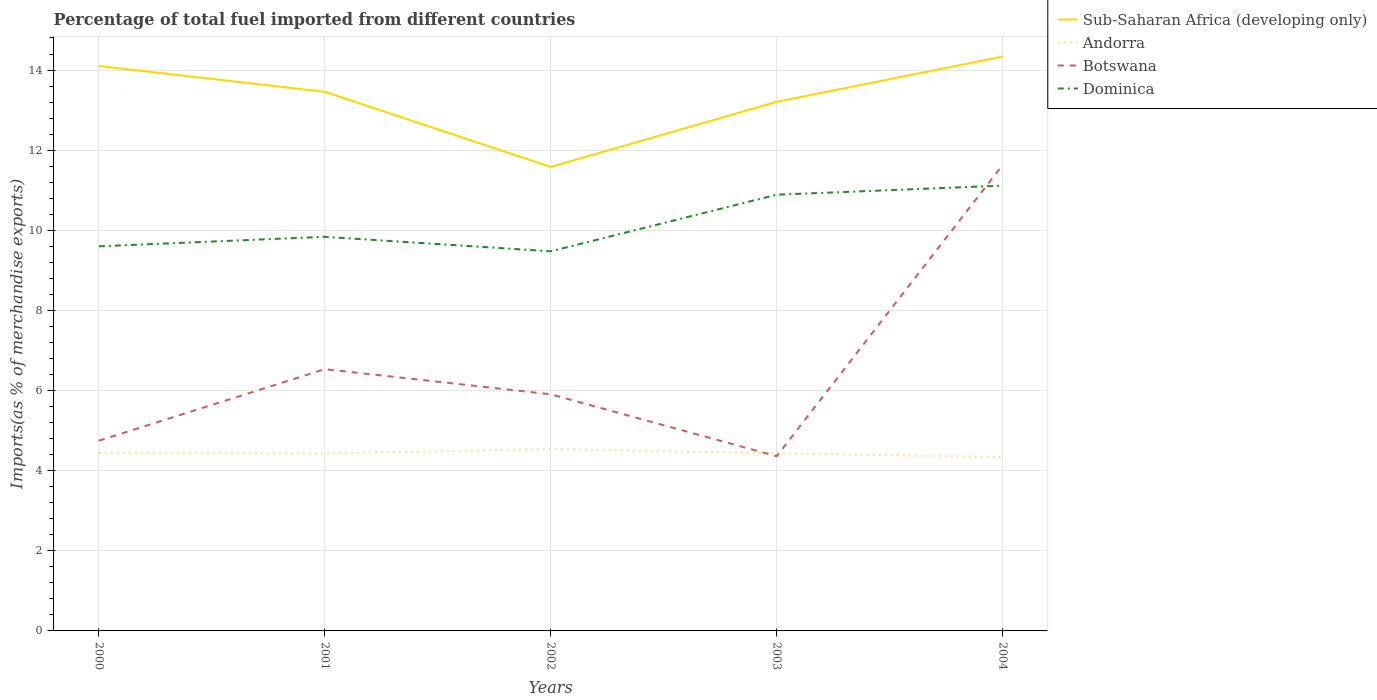How many different coloured lines are there?
Your answer should be compact. 4. Is the number of lines equal to the number of legend labels?
Keep it short and to the point. Yes. Across all years, what is the maximum percentage of imports to different countries in Andorra?
Ensure brevity in your answer.  4.34. What is the total percentage of imports to different countries in Andorra in the graph?
Keep it short and to the point. 0.09. What is the difference between the highest and the second highest percentage of imports to different countries in Andorra?
Offer a very short reply. 0.2. What is the difference between the highest and the lowest percentage of imports to different countries in Botswana?
Your answer should be compact. 1. How many lines are there?
Your answer should be very brief. 4. How many years are there in the graph?
Ensure brevity in your answer.  5. Are the values on the major ticks of Y-axis written in scientific E-notation?
Provide a short and direct response. No. Where does the legend appear in the graph?
Ensure brevity in your answer.  Top right. What is the title of the graph?
Your response must be concise. Percentage of total fuel imported from different countries. What is the label or title of the Y-axis?
Ensure brevity in your answer.  Imports(as % of merchandise exports). What is the Imports(as % of merchandise exports) of Sub-Saharan Africa (developing only) in 2000?
Your answer should be compact. 14.1. What is the Imports(as % of merchandise exports) of Andorra in 2000?
Ensure brevity in your answer.  4.44. What is the Imports(as % of merchandise exports) in Botswana in 2000?
Your answer should be very brief. 4.75. What is the Imports(as % of merchandise exports) in Dominica in 2000?
Your response must be concise. 9.6. What is the Imports(as % of merchandise exports) in Sub-Saharan Africa (developing only) in 2001?
Offer a very short reply. 13.46. What is the Imports(as % of merchandise exports) in Andorra in 2001?
Provide a succinct answer. 4.43. What is the Imports(as % of merchandise exports) in Botswana in 2001?
Make the answer very short. 6.53. What is the Imports(as % of merchandise exports) of Dominica in 2001?
Keep it short and to the point. 9.84. What is the Imports(as % of merchandise exports) in Sub-Saharan Africa (developing only) in 2002?
Ensure brevity in your answer.  11.58. What is the Imports(as % of merchandise exports) of Andorra in 2002?
Provide a succinct answer. 4.54. What is the Imports(as % of merchandise exports) of Botswana in 2002?
Your answer should be very brief. 5.91. What is the Imports(as % of merchandise exports) in Dominica in 2002?
Provide a short and direct response. 9.48. What is the Imports(as % of merchandise exports) of Sub-Saharan Africa (developing only) in 2003?
Your response must be concise. 13.21. What is the Imports(as % of merchandise exports) of Andorra in 2003?
Ensure brevity in your answer.  4.43. What is the Imports(as % of merchandise exports) of Botswana in 2003?
Provide a short and direct response. 4.36. What is the Imports(as % of merchandise exports) in Dominica in 2003?
Offer a terse response. 10.89. What is the Imports(as % of merchandise exports) in Sub-Saharan Africa (developing only) in 2004?
Your response must be concise. 14.34. What is the Imports(as % of merchandise exports) in Andorra in 2004?
Ensure brevity in your answer.  4.34. What is the Imports(as % of merchandise exports) in Botswana in 2004?
Give a very brief answer. 11.63. What is the Imports(as % of merchandise exports) of Dominica in 2004?
Ensure brevity in your answer.  11.12. Across all years, what is the maximum Imports(as % of merchandise exports) of Sub-Saharan Africa (developing only)?
Your answer should be compact. 14.34. Across all years, what is the maximum Imports(as % of merchandise exports) of Andorra?
Keep it short and to the point. 4.54. Across all years, what is the maximum Imports(as % of merchandise exports) in Botswana?
Provide a short and direct response. 11.63. Across all years, what is the maximum Imports(as % of merchandise exports) of Dominica?
Make the answer very short. 11.12. Across all years, what is the minimum Imports(as % of merchandise exports) in Sub-Saharan Africa (developing only)?
Offer a very short reply. 11.58. Across all years, what is the minimum Imports(as % of merchandise exports) of Andorra?
Offer a very short reply. 4.34. Across all years, what is the minimum Imports(as % of merchandise exports) in Botswana?
Give a very brief answer. 4.36. Across all years, what is the minimum Imports(as % of merchandise exports) of Dominica?
Your answer should be very brief. 9.48. What is the total Imports(as % of merchandise exports) in Sub-Saharan Africa (developing only) in the graph?
Provide a succinct answer. 66.68. What is the total Imports(as % of merchandise exports) of Andorra in the graph?
Offer a terse response. 22.18. What is the total Imports(as % of merchandise exports) of Botswana in the graph?
Ensure brevity in your answer.  33.18. What is the total Imports(as % of merchandise exports) in Dominica in the graph?
Make the answer very short. 50.92. What is the difference between the Imports(as % of merchandise exports) of Sub-Saharan Africa (developing only) in 2000 and that in 2001?
Your response must be concise. 0.64. What is the difference between the Imports(as % of merchandise exports) in Andorra in 2000 and that in 2001?
Offer a terse response. 0.01. What is the difference between the Imports(as % of merchandise exports) in Botswana in 2000 and that in 2001?
Offer a very short reply. -1.79. What is the difference between the Imports(as % of merchandise exports) of Dominica in 2000 and that in 2001?
Provide a succinct answer. -0.24. What is the difference between the Imports(as % of merchandise exports) in Sub-Saharan Africa (developing only) in 2000 and that in 2002?
Ensure brevity in your answer.  2.52. What is the difference between the Imports(as % of merchandise exports) of Andorra in 2000 and that in 2002?
Offer a terse response. -0.1. What is the difference between the Imports(as % of merchandise exports) in Botswana in 2000 and that in 2002?
Your answer should be compact. -1.16. What is the difference between the Imports(as % of merchandise exports) of Dominica in 2000 and that in 2002?
Offer a terse response. 0.13. What is the difference between the Imports(as % of merchandise exports) in Sub-Saharan Africa (developing only) in 2000 and that in 2003?
Provide a succinct answer. 0.89. What is the difference between the Imports(as % of merchandise exports) in Andorra in 2000 and that in 2003?
Give a very brief answer. 0. What is the difference between the Imports(as % of merchandise exports) of Botswana in 2000 and that in 2003?
Your response must be concise. 0.39. What is the difference between the Imports(as % of merchandise exports) in Dominica in 2000 and that in 2003?
Make the answer very short. -1.29. What is the difference between the Imports(as % of merchandise exports) of Sub-Saharan Africa (developing only) in 2000 and that in 2004?
Your response must be concise. -0.24. What is the difference between the Imports(as % of merchandise exports) in Andorra in 2000 and that in 2004?
Keep it short and to the point. 0.1. What is the difference between the Imports(as % of merchandise exports) in Botswana in 2000 and that in 2004?
Your response must be concise. -6.88. What is the difference between the Imports(as % of merchandise exports) in Dominica in 2000 and that in 2004?
Ensure brevity in your answer.  -1.52. What is the difference between the Imports(as % of merchandise exports) of Sub-Saharan Africa (developing only) in 2001 and that in 2002?
Your answer should be very brief. 1.88. What is the difference between the Imports(as % of merchandise exports) in Andorra in 2001 and that in 2002?
Make the answer very short. -0.11. What is the difference between the Imports(as % of merchandise exports) in Botswana in 2001 and that in 2002?
Ensure brevity in your answer.  0.63. What is the difference between the Imports(as % of merchandise exports) in Dominica in 2001 and that in 2002?
Your answer should be very brief. 0.36. What is the difference between the Imports(as % of merchandise exports) of Sub-Saharan Africa (developing only) in 2001 and that in 2003?
Your answer should be compact. 0.25. What is the difference between the Imports(as % of merchandise exports) in Andorra in 2001 and that in 2003?
Offer a terse response. -0. What is the difference between the Imports(as % of merchandise exports) in Botswana in 2001 and that in 2003?
Provide a short and direct response. 2.17. What is the difference between the Imports(as % of merchandise exports) in Dominica in 2001 and that in 2003?
Keep it short and to the point. -1.05. What is the difference between the Imports(as % of merchandise exports) in Sub-Saharan Africa (developing only) in 2001 and that in 2004?
Your answer should be compact. -0.88. What is the difference between the Imports(as % of merchandise exports) in Andorra in 2001 and that in 2004?
Offer a very short reply. 0.09. What is the difference between the Imports(as % of merchandise exports) in Botswana in 2001 and that in 2004?
Give a very brief answer. -5.09. What is the difference between the Imports(as % of merchandise exports) of Dominica in 2001 and that in 2004?
Provide a short and direct response. -1.28. What is the difference between the Imports(as % of merchandise exports) of Sub-Saharan Africa (developing only) in 2002 and that in 2003?
Give a very brief answer. -1.63. What is the difference between the Imports(as % of merchandise exports) in Andorra in 2002 and that in 2003?
Your answer should be compact. 0.11. What is the difference between the Imports(as % of merchandise exports) of Botswana in 2002 and that in 2003?
Make the answer very short. 1.55. What is the difference between the Imports(as % of merchandise exports) in Dominica in 2002 and that in 2003?
Ensure brevity in your answer.  -1.41. What is the difference between the Imports(as % of merchandise exports) of Sub-Saharan Africa (developing only) in 2002 and that in 2004?
Make the answer very short. -2.75. What is the difference between the Imports(as % of merchandise exports) in Andorra in 2002 and that in 2004?
Offer a terse response. 0.2. What is the difference between the Imports(as % of merchandise exports) in Botswana in 2002 and that in 2004?
Provide a short and direct response. -5.72. What is the difference between the Imports(as % of merchandise exports) in Dominica in 2002 and that in 2004?
Offer a terse response. -1.64. What is the difference between the Imports(as % of merchandise exports) of Sub-Saharan Africa (developing only) in 2003 and that in 2004?
Ensure brevity in your answer.  -1.13. What is the difference between the Imports(as % of merchandise exports) in Andorra in 2003 and that in 2004?
Provide a short and direct response. 0.1. What is the difference between the Imports(as % of merchandise exports) in Botswana in 2003 and that in 2004?
Make the answer very short. -7.27. What is the difference between the Imports(as % of merchandise exports) of Dominica in 2003 and that in 2004?
Keep it short and to the point. -0.23. What is the difference between the Imports(as % of merchandise exports) of Sub-Saharan Africa (developing only) in 2000 and the Imports(as % of merchandise exports) of Andorra in 2001?
Provide a succinct answer. 9.67. What is the difference between the Imports(as % of merchandise exports) of Sub-Saharan Africa (developing only) in 2000 and the Imports(as % of merchandise exports) of Botswana in 2001?
Ensure brevity in your answer.  7.57. What is the difference between the Imports(as % of merchandise exports) of Sub-Saharan Africa (developing only) in 2000 and the Imports(as % of merchandise exports) of Dominica in 2001?
Make the answer very short. 4.26. What is the difference between the Imports(as % of merchandise exports) in Andorra in 2000 and the Imports(as % of merchandise exports) in Botswana in 2001?
Your answer should be compact. -2.09. What is the difference between the Imports(as % of merchandise exports) in Andorra in 2000 and the Imports(as % of merchandise exports) in Dominica in 2001?
Keep it short and to the point. -5.4. What is the difference between the Imports(as % of merchandise exports) in Botswana in 2000 and the Imports(as % of merchandise exports) in Dominica in 2001?
Your answer should be compact. -5.09. What is the difference between the Imports(as % of merchandise exports) in Sub-Saharan Africa (developing only) in 2000 and the Imports(as % of merchandise exports) in Andorra in 2002?
Your answer should be very brief. 9.56. What is the difference between the Imports(as % of merchandise exports) in Sub-Saharan Africa (developing only) in 2000 and the Imports(as % of merchandise exports) in Botswana in 2002?
Make the answer very short. 8.19. What is the difference between the Imports(as % of merchandise exports) in Sub-Saharan Africa (developing only) in 2000 and the Imports(as % of merchandise exports) in Dominica in 2002?
Offer a very short reply. 4.63. What is the difference between the Imports(as % of merchandise exports) of Andorra in 2000 and the Imports(as % of merchandise exports) of Botswana in 2002?
Your response must be concise. -1.47. What is the difference between the Imports(as % of merchandise exports) of Andorra in 2000 and the Imports(as % of merchandise exports) of Dominica in 2002?
Your answer should be compact. -5.04. What is the difference between the Imports(as % of merchandise exports) of Botswana in 2000 and the Imports(as % of merchandise exports) of Dominica in 2002?
Offer a terse response. -4.73. What is the difference between the Imports(as % of merchandise exports) in Sub-Saharan Africa (developing only) in 2000 and the Imports(as % of merchandise exports) in Andorra in 2003?
Give a very brief answer. 9.67. What is the difference between the Imports(as % of merchandise exports) in Sub-Saharan Africa (developing only) in 2000 and the Imports(as % of merchandise exports) in Botswana in 2003?
Offer a terse response. 9.74. What is the difference between the Imports(as % of merchandise exports) in Sub-Saharan Africa (developing only) in 2000 and the Imports(as % of merchandise exports) in Dominica in 2003?
Give a very brief answer. 3.21. What is the difference between the Imports(as % of merchandise exports) of Andorra in 2000 and the Imports(as % of merchandise exports) of Botswana in 2003?
Offer a very short reply. 0.08. What is the difference between the Imports(as % of merchandise exports) in Andorra in 2000 and the Imports(as % of merchandise exports) in Dominica in 2003?
Your answer should be compact. -6.45. What is the difference between the Imports(as % of merchandise exports) in Botswana in 2000 and the Imports(as % of merchandise exports) in Dominica in 2003?
Ensure brevity in your answer.  -6.14. What is the difference between the Imports(as % of merchandise exports) in Sub-Saharan Africa (developing only) in 2000 and the Imports(as % of merchandise exports) in Andorra in 2004?
Provide a short and direct response. 9.76. What is the difference between the Imports(as % of merchandise exports) in Sub-Saharan Africa (developing only) in 2000 and the Imports(as % of merchandise exports) in Botswana in 2004?
Ensure brevity in your answer.  2.47. What is the difference between the Imports(as % of merchandise exports) in Sub-Saharan Africa (developing only) in 2000 and the Imports(as % of merchandise exports) in Dominica in 2004?
Your response must be concise. 2.98. What is the difference between the Imports(as % of merchandise exports) in Andorra in 2000 and the Imports(as % of merchandise exports) in Botswana in 2004?
Offer a very short reply. -7.19. What is the difference between the Imports(as % of merchandise exports) of Andorra in 2000 and the Imports(as % of merchandise exports) of Dominica in 2004?
Your answer should be compact. -6.68. What is the difference between the Imports(as % of merchandise exports) of Botswana in 2000 and the Imports(as % of merchandise exports) of Dominica in 2004?
Keep it short and to the point. -6.37. What is the difference between the Imports(as % of merchandise exports) in Sub-Saharan Africa (developing only) in 2001 and the Imports(as % of merchandise exports) in Andorra in 2002?
Your response must be concise. 8.92. What is the difference between the Imports(as % of merchandise exports) of Sub-Saharan Africa (developing only) in 2001 and the Imports(as % of merchandise exports) of Botswana in 2002?
Keep it short and to the point. 7.55. What is the difference between the Imports(as % of merchandise exports) of Sub-Saharan Africa (developing only) in 2001 and the Imports(as % of merchandise exports) of Dominica in 2002?
Keep it short and to the point. 3.98. What is the difference between the Imports(as % of merchandise exports) in Andorra in 2001 and the Imports(as % of merchandise exports) in Botswana in 2002?
Provide a short and direct response. -1.48. What is the difference between the Imports(as % of merchandise exports) of Andorra in 2001 and the Imports(as % of merchandise exports) of Dominica in 2002?
Your answer should be very brief. -5.05. What is the difference between the Imports(as % of merchandise exports) of Botswana in 2001 and the Imports(as % of merchandise exports) of Dominica in 2002?
Keep it short and to the point. -2.94. What is the difference between the Imports(as % of merchandise exports) of Sub-Saharan Africa (developing only) in 2001 and the Imports(as % of merchandise exports) of Andorra in 2003?
Your answer should be compact. 9.02. What is the difference between the Imports(as % of merchandise exports) of Sub-Saharan Africa (developing only) in 2001 and the Imports(as % of merchandise exports) of Botswana in 2003?
Give a very brief answer. 9.1. What is the difference between the Imports(as % of merchandise exports) of Sub-Saharan Africa (developing only) in 2001 and the Imports(as % of merchandise exports) of Dominica in 2003?
Keep it short and to the point. 2.57. What is the difference between the Imports(as % of merchandise exports) of Andorra in 2001 and the Imports(as % of merchandise exports) of Botswana in 2003?
Provide a succinct answer. 0.07. What is the difference between the Imports(as % of merchandise exports) of Andorra in 2001 and the Imports(as % of merchandise exports) of Dominica in 2003?
Make the answer very short. -6.46. What is the difference between the Imports(as % of merchandise exports) of Botswana in 2001 and the Imports(as % of merchandise exports) of Dominica in 2003?
Give a very brief answer. -4.35. What is the difference between the Imports(as % of merchandise exports) in Sub-Saharan Africa (developing only) in 2001 and the Imports(as % of merchandise exports) in Andorra in 2004?
Provide a succinct answer. 9.12. What is the difference between the Imports(as % of merchandise exports) of Sub-Saharan Africa (developing only) in 2001 and the Imports(as % of merchandise exports) of Botswana in 2004?
Provide a succinct answer. 1.83. What is the difference between the Imports(as % of merchandise exports) in Sub-Saharan Africa (developing only) in 2001 and the Imports(as % of merchandise exports) in Dominica in 2004?
Give a very brief answer. 2.34. What is the difference between the Imports(as % of merchandise exports) of Andorra in 2001 and the Imports(as % of merchandise exports) of Botswana in 2004?
Offer a very short reply. -7.2. What is the difference between the Imports(as % of merchandise exports) of Andorra in 2001 and the Imports(as % of merchandise exports) of Dominica in 2004?
Offer a very short reply. -6.69. What is the difference between the Imports(as % of merchandise exports) in Botswana in 2001 and the Imports(as % of merchandise exports) in Dominica in 2004?
Your answer should be very brief. -4.58. What is the difference between the Imports(as % of merchandise exports) of Sub-Saharan Africa (developing only) in 2002 and the Imports(as % of merchandise exports) of Andorra in 2003?
Make the answer very short. 7.15. What is the difference between the Imports(as % of merchandise exports) of Sub-Saharan Africa (developing only) in 2002 and the Imports(as % of merchandise exports) of Botswana in 2003?
Offer a terse response. 7.22. What is the difference between the Imports(as % of merchandise exports) in Sub-Saharan Africa (developing only) in 2002 and the Imports(as % of merchandise exports) in Dominica in 2003?
Ensure brevity in your answer.  0.69. What is the difference between the Imports(as % of merchandise exports) of Andorra in 2002 and the Imports(as % of merchandise exports) of Botswana in 2003?
Ensure brevity in your answer.  0.18. What is the difference between the Imports(as % of merchandise exports) in Andorra in 2002 and the Imports(as % of merchandise exports) in Dominica in 2003?
Offer a very short reply. -6.35. What is the difference between the Imports(as % of merchandise exports) of Botswana in 2002 and the Imports(as % of merchandise exports) of Dominica in 2003?
Ensure brevity in your answer.  -4.98. What is the difference between the Imports(as % of merchandise exports) of Sub-Saharan Africa (developing only) in 2002 and the Imports(as % of merchandise exports) of Andorra in 2004?
Keep it short and to the point. 7.24. What is the difference between the Imports(as % of merchandise exports) of Sub-Saharan Africa (developing only) in 2002 and the Imports(as % of merchandise exports) of Botswana in 2004?
Your answer should be very brief. -0.05. What is the difference between the Imports(as % of merchandise exports) in Sub-Saharan Africa (developing only) in 2002 and the Imports(as % of merchandise exports) in Dominica in 2004?
Keep it short and to the point. 0.47. What is the difference between the Imports(as % of merchandise exports) of Andorra in 2002 and the Imports(as % of merchandise exports) of Botswana in 2004?
Provide a short and direct response. -7.09. What is the difference between the Imports(as % of merchandise exports) in Andorra in 2002 and the Imports(as % of merchandise exports) in Dominica in 2004?
Ensure brevity in your answer.  -6.58. What is the difference between the Imports(as % of merchandise exports) of Botswana in 2002 and the Imports(as % of merchandise exports) of Dominica in 2004?
Provide a succinct answer. -5.21. What is the difference between the Imports(as % of merchandise exports) of Sub-Saharan Africa (developing only) in 2003 and the Imports(as % of merchandise exports) of Andorra in 2004?
Give a very brief answer. 8.87. What is the difference between the Imports(as % of merchandise exports) of Sub-Saharan Africa (developing only) in 2003 and the Imports(as % of merchandise exports) of Botswana in 2004?
Keep it short and to the point. 1.58. What is the difference between the Imports(as % of merchandise exports) in Sub-Saharan Africa (developing only) in 2003 and the Imports(as % of merchandise exports) in Dominica in 2004?
Your response must be concise. 2.09. What is the difference between the Imports(as % of merchandise exports) of Andorra in 2003 and the Imports(as % of merchandise exports) of Botswana in 2004?
Provide a succinct answer. -7.19. What is the difference between the Imports(as % of merchandise exports) in Andorra in 2003 and the Imports(as % of merchandise exports) in Dominica in 2004?
Keep it short and to the point. -6.68. What is the difference between the Imports(as % of merchandise exports) in Botswana in 2003 and the Imports(as % of merchandise exports) in Dominica in 2004?
Offer a very short reply. -6.75. What is the average Imports(as % of merchandise exports) of Sub-Saharan Africa (developing only) per year?
Provide a succinct answer. 13.34. What is the average Imports(as % of merchandise exports) of Andorra per year?
Provide a succinct answer. 4.44. What is the average Imports(as % of merchandise exports) in Botswana per year?
Make the answer very short. 6.64. What is the average Imports(as % of merchandise exports) of Dominica per year?
Offer a very short reply. 10.18. In the year 2000, what is the difference between the Imports(as % of merchandise exports) of Sub-Saharan Africa (developing only) and Imports(as % of merchandise exports) of Andorra?
Make the answer very short. 9.66. In the year 2000, what is the difference between the Imports(as % of merchandise exports) in Sub-Saharan Africa (developing only) and Imports(as % of merchandise exports) in Botswana?
Your response must be concise. 9.35. In the year 2000, what is the difference between the Imports(as % of merchandise exports) of Sub-Saharan Africa (developing only) and Imports(as % of merchandise exports) of Dominica?
Your response must be concise. 4.5. In the year 2000, what is the difference between the Imports(as % of merchandise exports) of Andorra and Imports(as % of merchandise exports) of Botswana?
Offer a very short reply. -0.31. In the year 2000, what is the difference between the Imports(as % of merchandise exports) of Andorra and Imports(as % of merchandise exports) of Dominica?
Keep it short and to the point. -5.16. In the year 2000, what is the difference between the Imports(as % of merchandise exports) of Botswana and Imports(as % of merchandise exports) of Dominica?
Your response must be concise. -4.85. In the year 2001, what is the difference between the Imports(as % of merchandise exports) in Sub-Saharan Africa (developing only) and Imports(as % of merchandise exports) in Andorra?
Provide a short and direct response. 9.03. In the year 2001, what is the difference between the Imports(as % of merchandise exports) of Sub-Saharan Africa (developing only) and Imports(as % of merchandise exports) of Botswana?
Your answer should be compact. 6.92. In the year 2001, what is the difference between the Imports(as % of merchandise exports) of Sub-Saharan Africa (developing only) and Imports(as % of merchandise exports) of Dominica?
Keep it short and to the point. 3.62. In the year 2001, what is the difference between the Imports(as % of merchandise exports) in Andorra and Imports(as % of merchandise exports) in Botswana?
Offer a terse response. -2.1. In the year 2001, what is the difference between the Imports(as % of merchandise exports) of Andorra and Imports(as % of merchandise exports) of Dominica?
Offer a very short reply. -5.41. In the year 2001, what is the difference between the Imports(as % of merchandise exports) in Botswana and Imports(as % of merchandise exports) in Dominica?
Your answer should be very brief. -3.3. In the year 2002, what is the difference between the Imports(as % of merchandise exports) in Sub-Saharan Africa (developing only) and Imports(as % of merchandise exports) in Andorra?
Your response must be concise. 7.04. In the year 2002, what is the difference between the Imports(as % of merchandise exports) in Sub-Saharan Africa (developing only) and Imports(as % of merchandise exports) in Botswana?
Your answer should be very brief. 5.68. In the year 2002, what is the difference between the Imports(as % of merchandise exports) of Sub-Saharan Africa (developing only) and Imports(as % of merchandise exports) of Dominica?
Offer a terse response. 2.11. In the year 2002, what is the difference between the Imports(as % of merchandise exports) in Andorra and Imports(as % of merchandise exports) in Botswana?
Give a very brief answer. -1.37. In the year 2002, what is the difference between the Imports(as % of merchandise exports) in Andorra and Imports(as % of merchandise exports) in Dominica?
Offer a terse response. -4.93. In the year 2002, what is the difference between the Imports(as % of merchandise exports) in Botswana and Imports(as % of merchandise exports) in Dominica?
Your answer should be very brief. -3.57. In the year 2003, what is the difference between the Imports(as % of merchandise exports) of Sub-Saharan Africa (developing only) and Imports(as % of merchandise exports) of Andorra?
Provide a succinct answer. 8.77. In the year 2003, what is the difference between the Imports(as % of merchandise exports) of Sub-Saharan Africa (developing only) and Imports(as % of merchandise exports) of Botswana?
Offer a very short reply. 8.85. In the year 2003, what is the difference between the Imports(as % of merchandise exports) in Sub-Saharan Africa (developing only) and Imports(as % of merchandise exports) in Dominica?
Give a very brief answer. 2.32. In the year 2003, what is the difference between the Imports(as % of merchandise exports) in Andorra and Imports(as % of merchandise exports) in Botswana?
Offer a very short reply. 0.07. In the year 2003, what is the difference between the Imports(as % of merchandise exports) of Andorra and Imports(as % of merchandise exports) of Dominica?
Give a very brief answer. -6.45. In the year 2003, what is the difference between the Imports(as % of merchandise exports) of Botswana and Imports(as % of merchandise exports) of Dominica?
Offer a very short reply. -6.53. In the year 2004, what is the difference between the Imports(as % of merchandise exports) in Sub-Saharan Africa (developing only) and Imports(as % of merchandise exports) in Andorra?
Give a very brief answer. 10. In the year 2004, what is the difference between the Imports(as % of merchandise exports) of Sub-Saharan Africa (developing only) and Imports(as % of merchandise exports) of Botswana?
Your response must be concise. 2.71. In the year 2004, what is the difference between the Imports(as % of merchandise exports) in Sub-Saharan Africa (developing only) and Imports(as % of merchandise exports) in Dominica?
Your answer should be compact. 3.22. In the year 2004, what is the difference between the Imports(as % of merchandise exports) in Andorra and Imports(as % of merchandise exports) in Botswana?
Ensure brevity in your answer.  -7.29. In the year 2004, what is the difference between the Imports(as % of merchandise exports) in Andorra and Imports(as % of merchandise exports) in Dominica?
Your answer should be compact. -6.78. In the year 2004, what is the difference between the Imports(as % of merchandise exports) in Botswana and Imports(as % of merchandise exports) in Dominica?
Your answer should be very brief. 0.51. What is the ratio of the Imports(as % of merchandise exports) of Sub-Saharan Africa (developing only) in 2000 to that in 2001?
Your response must be concise. 1.05. What is the ratio of the Imports(as % of merchandise exports) in Botswana in 2000 to that in 2001?
Give a very brief answer. 0.73. What is the ratio of the Imports(as % of merchandise exports) of Dominica in 2000 to that in 2001?
Make the answer very short. 0.98. What is the ratio of the Imports(as % of merchandise exports) of Sub-Saharan Africa (developing only) in 2000 to that in 2002?
Ensure brevity in your answer.  1.22. What is the ratio of the Imports(as % of merchandise exports) of Andorra in 2000 to that in 2002?
Give a very brief answer. 0.98. What is the ratio of the Imports(as % of merchandise exports) of Botswana in 2000 to that in 2002?
Your answer should be very brief. 0.8. What is the ratio of the Imports(as % of merchandise exports) of Dominica in 2000 to that in 2002?
Ensure brevity in your answer.  1.01. What is the ratio of the Imports(as % of merchandise exports) in Sub-Saharan Africa (developing only) in 2000 to that in 2003?
Make the answer very short. 1.07. What is the ratio of the Imports(as % of merchandise exports) of Andorra in 2000 to that in 2003?
Your response must be concise. 1. What is the ratio of the Imports(as % of merchandise exports) of Botswana in 2000 to that in 2003?
Offer a very short reply. 1.09. What is the ratio of the Imports(as % of merchandise exports) in Dominica in 2000 to that in 2003?
Provide a succinct answer. 0.88. What is the ratio of the Imports(as % of merchandise exports) in Sub-Saharan Africa (developing only) in 2000 to that in 2004?
Provide a succinct answer. 0.98. What is the ratio of the Imports(as % of merchandise exports) in Andorra in 2000 to that in 2004?
Provide a succinct answer. 1.02. What is the ratio of the Imports(as % of merchandise exports) of Botswana in 2000 to that in 2004?
Your response must be concise. 0.41. What is the ratio of the Imports(as % of merchandise exports) of Dominica in 2000 to that in 2004?
Your answer should be very brief. 0.86. What is the ratio of the Imports(as % of merchandise exports) in Sub-Saharan Africa (developing only) in 2001 to that in 2002?
Provide a succinct answer. 1.16. What is the ratio of the Imports(as % of merchandise exports) of Andorra in 2001 to that in 2002?
Your answer should be compact. 0.98. What is the ratio of the Imports(as % of merchandise exports) of Botswana in 2001 to that in 2002?
Provide a succinct answer. 1.11. What is the ratio of the Imports(as % of merchandise exports) of Dominica in 2001 to that in 2002?
Your response must be concise. 1.04. What is the ratio of the Imports(as % of merchandise exports) of Sub-Saharan Africa (developing only) in 2001 to that in 2003?
Make the answer very short. 1.02. What is the ratio of the Imports(as % of merchandise exports) in Botswana in 2001 to that in 2003?
Keep it short and to the point. 1.5. What is the ratio of the Imports(as % of merchandise exports) in Dominica in 2001 to that in 2003?
Make the answer very short. 0.9. What is the ratio of the Imports(as % of merchandise exports) in Sub-Saharan Africa (developing only) in 2001 to that in 2004?
Offer a terse response. 0.94. What is the ratio of the Imports(as % of merchandise exports) of Andorra in 2001 to that in 2004?
Your response must be concise. 1.02. What is the ratio of the Imports(as % of merchandise exports) of Botswana in 2001 to that in 2004?
Keep it short and to the point. 0.56. What is the ratio of the Imports(as % of merchandise exports) in Dominica in 2001 to that in 2004?
Offer a terse response. 0.89. What is the ratio of the Imports(as % of merchandise exports) of Sub-Saharan Africa (developing only) in 2002 to that in 2003?
Your answer should be very brief. 0.88. What is the ratio of the Imports(as % of merchandise exports) in Andorra in 2002 to that in 2003?
Offer a very short reply. 1.02. What is the ratio of the Imports(as % of merchandise exports) in Botswana in 2002 to that in 2003?
Ensure brevity in your answer.  1.35. What is the ratio of the Imports(as % of merchandise exports) in Dominica in 2002 to that in 2003?
Provide a succinct answer. 0.87. What is the ratio of the Imports(as % of merchandise exports) of Sub-Saharan Africa (developing only) in 2002 to that in 2004?
Offer a terse response. 0.81. What is the ratio of the Imports(as % of merchandise exports) in Andorra in 2002 to that in 2004?
Offer a very short reply. 1.05. What is the ratio of the Imports(as % of merchandise exports) in Botswana in 2002 to that in 2004?
Offer a terse response. 0.51. What is the ratio of the Imports(as % of merchandise exports) of Dominica in 2002 to that in 2004?
Provide a short and direct response. 0.85. What is the ratio of the Imports(as % of merchandise exports) of Sub-Saharan Africa (developing only) in 2003 to that in 2004?
Ensure brevity in your answer.  0.92. What is the ratio of the Imports(as % of merchandise exports) of Andorra in 2003 to that in 2004?
Make the answer very short. 1.02. What is the ratio of the Imports(as % of merchandise exports) of Botswana in 2003 to that in 2004?
Your answer should be compact. 0.38. What is the ratio of the Imports(as % of merchandise exports) of Dominica in 2003 to that in 2004?
Provide a short and direct response. 0.98. What is the difference between the highest and the second highest Imports(as % of merchandise exports) of Sub-Saharan Africa (developing only)?
Your answer should be compact. 0.24. What is the difference between the highest and the second highest Imports(as % of merchandise exports) in Andorra?
Provide a short and direct response. 0.1. What is the difference between the highest and the second highest Imports(as % of merchandise exports) in Botswana?
Make the answer very short. 5.09. What is the difference between the highest and the second highest Imports(as % of merchandise exports) in Dominica?
Provide a short and direct response. 0.23. What is the difference between the highest and the lowest Imports(as % of merchandise exports) in Sub-Saharan Africa (developing only)?
Provide a succinct answer. 2.75. What is the difference between the highest and the lowest Imports(as % of merchandise exports) in Andorra?
Offer a very short reply. 0.2. What is the difference between the highest and the lowest Imports(as % of merchandise exports) of Botswana?
Keep it short and to the point. 7.27. What is the difference between the highest and the lowest Imports(as % of merchandise exports) in Dominica?
Your response must be concise. 1.64. 